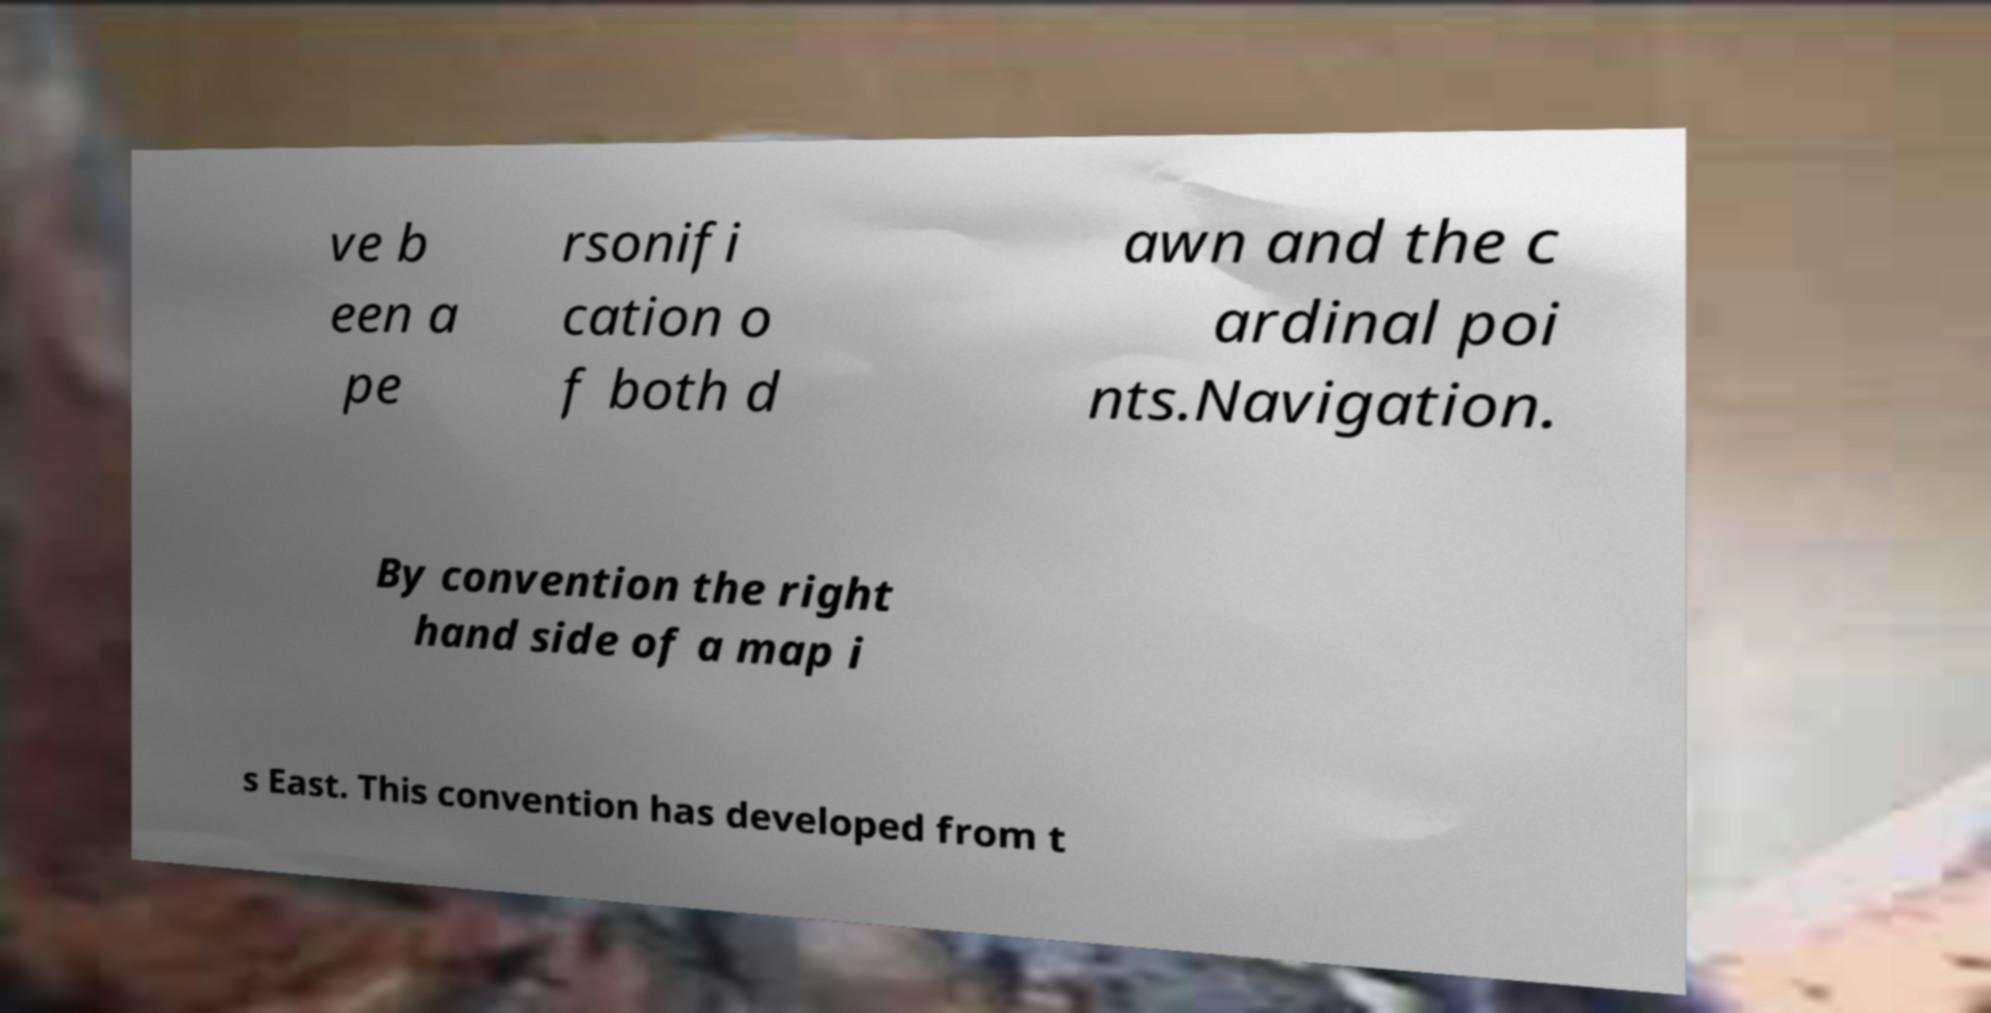Please identify and transcribe the text found in this image. ve b een a pe rsonifi cation o f both d awn and the c ardinal poi nts.Navigation. By convention the right hand side of a map i s East. This convention has developed from t 